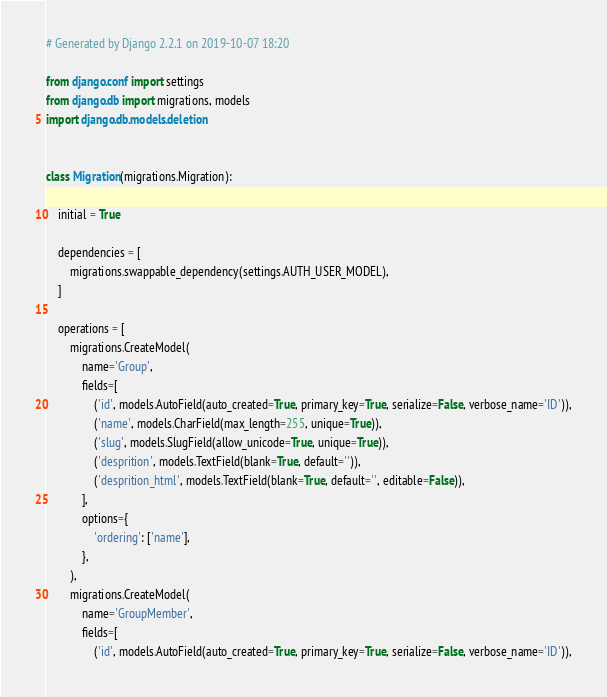<code> <loc_0><loc_0><loc_500><loc_500><_Python_># Generated by Django 2.2.1 on 2019-10-07 18:20

from django.conf import settings
from django.db import migrations, models
import django.db.models.deletion


class Migration(migrations.Migration):

    initial = True

    dependencies = [
        migrations.swappable_dependency(settings.AUTH_USER_MODEL),
    ]

    operations = [
        migrations.CreateModel(
            name='Group',
            fields=[
                ('id', models.AutoField(auto_created=True, primary_key=True, serialize=False, verbose_name='ID')),
                ('name', models.CharField(max_length=255, unique=True)),
                ('slug', models.SlugField(allow_unicode=True, unique=True)),
                ('desprition', models.TextField(blank=True, default='')),
                ('desprition_html', models.TextField(blank=True, default='', editable=False)),
            ],
            options={
                'ordering': ['name'],
            },
        ),
        migrations.CreateModel(
            name='GroupMember',
            fields=[
                ('id', models.AutoField(auto_created=True, primary_key=True, serialize=False, verbose_name='ID')),</code> 